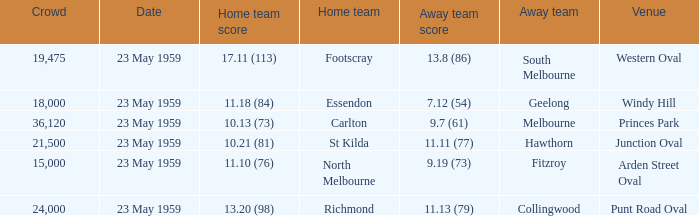What was the home team's score at the game held at Punt Road Oval? 13.20 (98). 